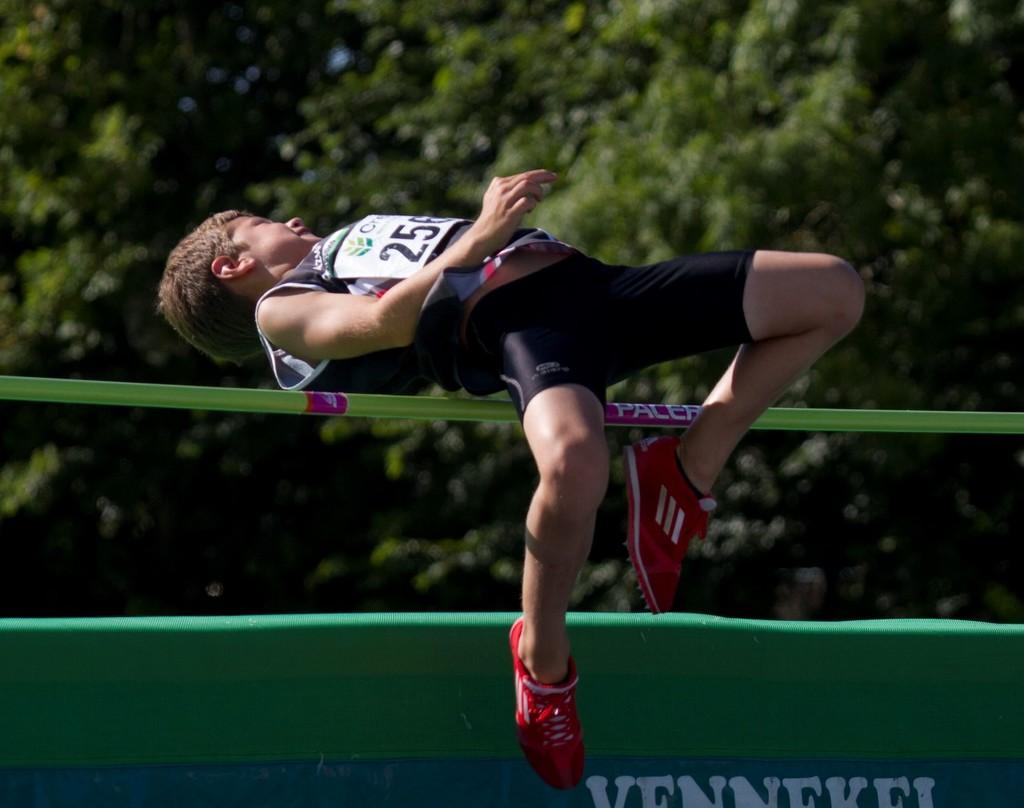What is the number on the jumpers chest?
Your answer should be very brief. 256. 